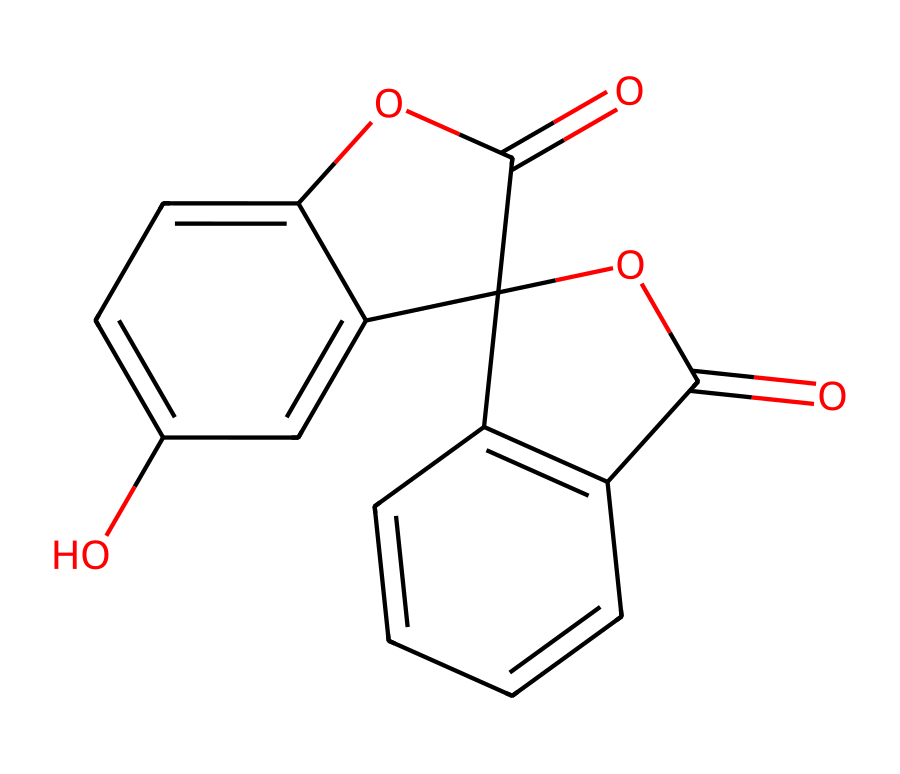What is the molecular formula of this dye? To determine the molecular formula, count the number of each type of atom in the displayed SMILES representation. The counts reveal there are 15 carbon (C) atoms, 10 hydrogen (H) atoms, 5 oxygen (O) atoms, leading to the formula C15H10O5.
Answer: C15H10O5 How many rings are present in the structure? Analyze the structure for cyclic components. In the provided SMILES, there are three distinct fused ring systems visible, confirmed by the presence of multiple numbers indicating bond connections.
Answer: 3 Does the structure contain any hydroxyl groups? Identify hydroxyl (–OH) groups in the chemical by looking for oxygen atoms bonded to a carbon atom directly. The structure shows one hydroxyl group present.
Answer: Yes What functional groups are present in this dye? Examine the chemical structure for recognizable functional groups. The notable functional groups include esters (due to –COO–) and hydroxyl groups (–OH), indicating that it has both functionalities.
Answer: ester, hydroxyl Which part of the structure contributes to its fluorescence? The presence of conjugated double bonds creates a chromophore, which is often responsible for fluorescence. The extensive pi-electron system indicated by alternating double bonds in the fused rings enables absorption of light, contributing to fluorescence.
Answer: conjugated double bonds 